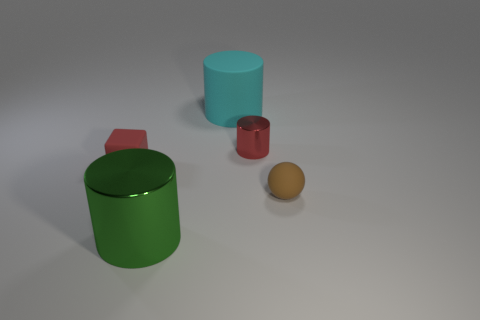What is the color of the thing that is behind the small brown matte sphere and on the right side of the cyan rubber cylinder?
Your answer should be very brief. Red. Is the number of matte balls behind the tiny matte ball greater than the number of matte cylinders to the left of the red matte thing?
Offer a terse response. No. What color is the small matte object right of the green thing?
Your answer should be very brief. Brown. There is a red shiny thing that is in front of the big cyan rubber object; does it have the same shape as the matte thing to the right of the big cyan cylinder?
Offer a very short reply. No. Is there a yellow metal cylinder of the same size as the red cylinder?
Your answer should be compact. No. There is a large object behind the brown ball; what is it made of?
Give a very brief answer. Rubber. Do the cylinder that is in front of the tiny red matte object and the tiny sphere have the same material?
Provide a short and direct response. No. Are there any rubber cylinders?
Provide a succinct answer. Yes. There is a thing that is the same material as the large green cylinder; what is its color?
Provide a short and direct response. Red. What is the color of the tiny thing behind the tiny rubber object behind the tiny matte object that is right of the large green shiny cylinder?
Give a very brief answer. Red. 